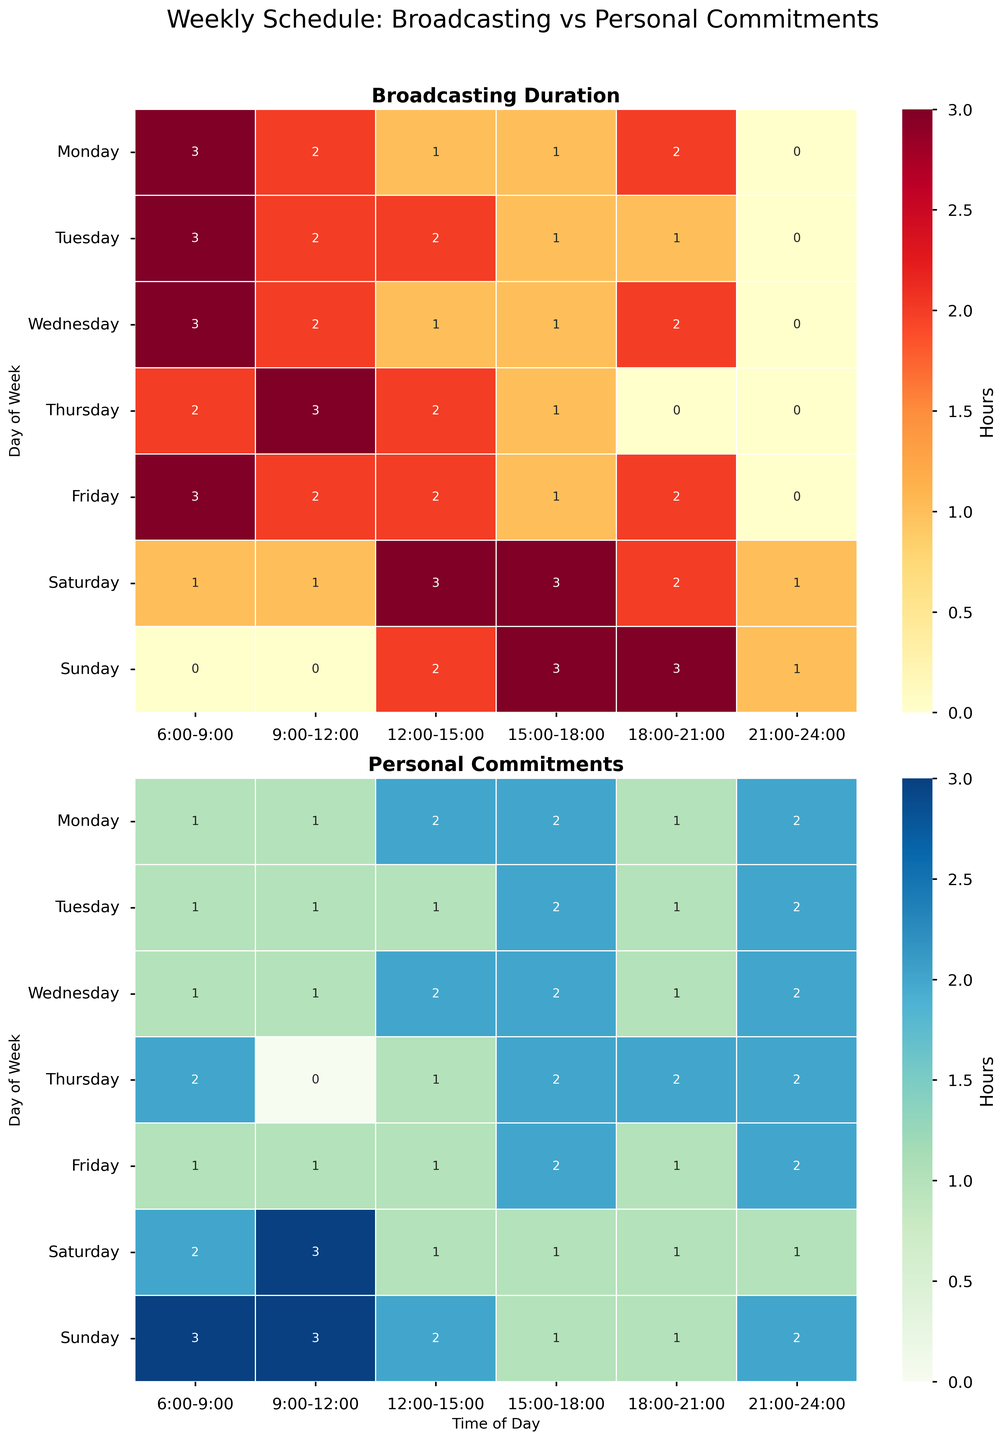What is the title of the first heatmap? The title of the first heatmap can be found at the top of the heatmap in bold. It reads "Broadcasting Duration", which is displayed prominently to indicate what the heatmap represents. It immediately follows the top panel of the figure.
Answer: Broadcasting Duration Which day has the maximum broadcasting duration between 6:00-9:00? To find the maximum broadcasting duration between 6:00-9:00, scan the first row of each day in the broadcasting heatmap. The values to look for are those in the time slot "6:00-9:00". The highest value in this row is 3, which appears on Monday, Tuesday, Wednesday, Friday, and Saturday.
Answer: Monday, Tuesday, Wednesday, Friday, Saturday How many hours are allocated to personal commitments on Tuesday between 12:00-15:00? Locate the cell corresponding to Tuesday and the time slot 12:00-15:00 in the personal commitments heatmap. Reading the annotated value within that cell gives you the number of hours allocated to personal commitments. The value shown is 1.
Answer: 1 On which days do your personal commitments exceed your broadcasting duration between 18:00-21:00? Compare the broadcasting and personal commitments heatmaps for the time slot 18:00-21:00. Scan for days where the value in the personal commitments heatmap is greater than the value in the broadcasting heatmap. The days meeting this criterion are Thursday, Sunday, and Saturday.
Answer: Thursday, Sunday What is the range of broadcasting hours on Saturday? To find the range, first identify the smallest and largest values in the broadcasting heatmap on Saturday by examining all the cells corresponding to Saturday. The smallest value is 1 and the largest is 3. The range is calculated as the difference between these values: 3 - 1 = 2.
Answer: 2 Which weekdays have a broadcasting duration of zero between 21:00-24:00? Locate the 21:00-24:00 time slot in the broadcasting heatmap. Scan the corresponding column to identify the days with a value of zero. The days with zero broadcasting duration are Monday, Tuesday, Wednesday, Thursday, and Friday.
Answer: Monday, Tuesday, Wednesday, Thursday, Friday What is the total broadcasting duration on Monday? Locate all the cells in the broadcasting heatmap for Monday and sum the annotated values in these cells. Adding up the durations: 3 + 2 + 1 + 1 + 2 + 0 = 9 hours.
Answer: 9 Which day shows the least personal commitment between 15:00-18:00? Locate the column corresponding to 15:00-18:00 in the personal commitments heatmap, and identify the smallest value. All days have a value of 2 except Tuesday and Thursday with 1. Out of these, Tuesday and Thursday have the least personal commitments.
Answer: Tuesday, Thursday What is the average personal commitment time on Friday? Find all the cells in the personal commitments heatmap corresponding to Friday. Add these values: 1 + 1 + 1 + 2 + 1 + 2 = 8 hours. Divide this total by the number of time slots (6) to find the average. 8 / 6 ≈ 1.33 hours.
Answer: 1.33 During which time slot is the broadcasting duration consistent across all weekdays? To determine consistency, we need to check for equal values in a particular time slot across all weekdays (Monday to Friday) in the broadcasting heatmap. The time slot 21:00-24:00 has a consistent value of 0 across Monday, Tuesday, Wednesday, Thursday, and Friday.
Answer: 21:00-24:00 